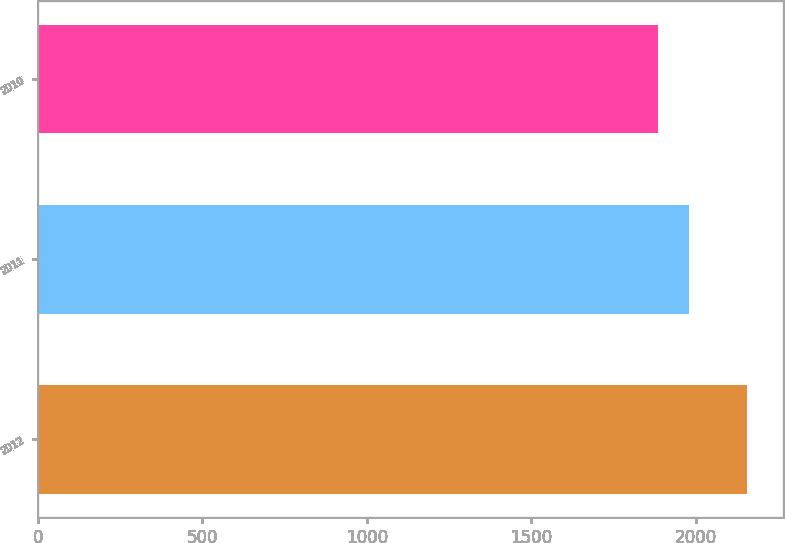<chart> <loc_0><loc_0><loc_500><loc_500><bar_chart><fcel>2012<fcel>2011<fcel>2010<nl><fcel>2156.9<fcel>1979.1<fcel>1886.1<nl></chart> 